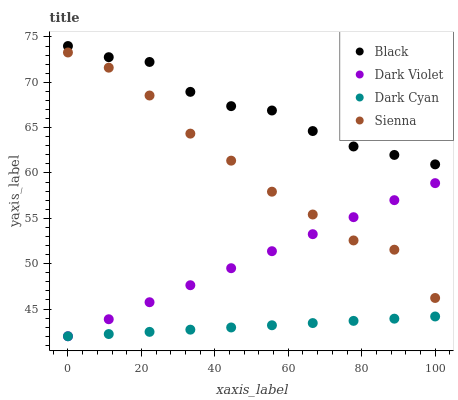Does Dark Cyan have the minimum area under the curve?
Answer yes or no. Yes. Does Black have the maximum area under the curve?
Answer yes or no. Yes. Does Sienna have the minimum area under the curve?
Answer yes or no. No. Does Sienna have the maximum area under the curve?
Answer yes or no. No. Is Dark Violet the smoothest?
Answer yes or no. Yes. Is Sienna the roughest?
Answer yes or no. Yes. Is Black the smoothest?
Answer yes or no. No. Is Black the roughest?
Answer yes or no. No. Does Dark Cyan have the lowest value?
Answer yes or no. Yes. Does Sienna have the lowest value?
Answer yes or no. No. Does Black have the highest value?
Answer yes or no. Yes. Does Sienna have the highest value?
Answer yes or no. No. Is Dark Cyan less than Sienna?
Answer yes or no. Yes. Is Black greater than Dark Cyan?
Answer yes or no. Yes. Does Dark Violet intersect Dark Cyan?
Answer yes or no. Yes. Is Dark Violet less than Dark Cyan?
Answer yes or no. No. Is Dark Violet greater than Dark Cyan?
Answer yes or no. No. Does Dark Cyan intersect Sienna?
Answer yes or no. No. 